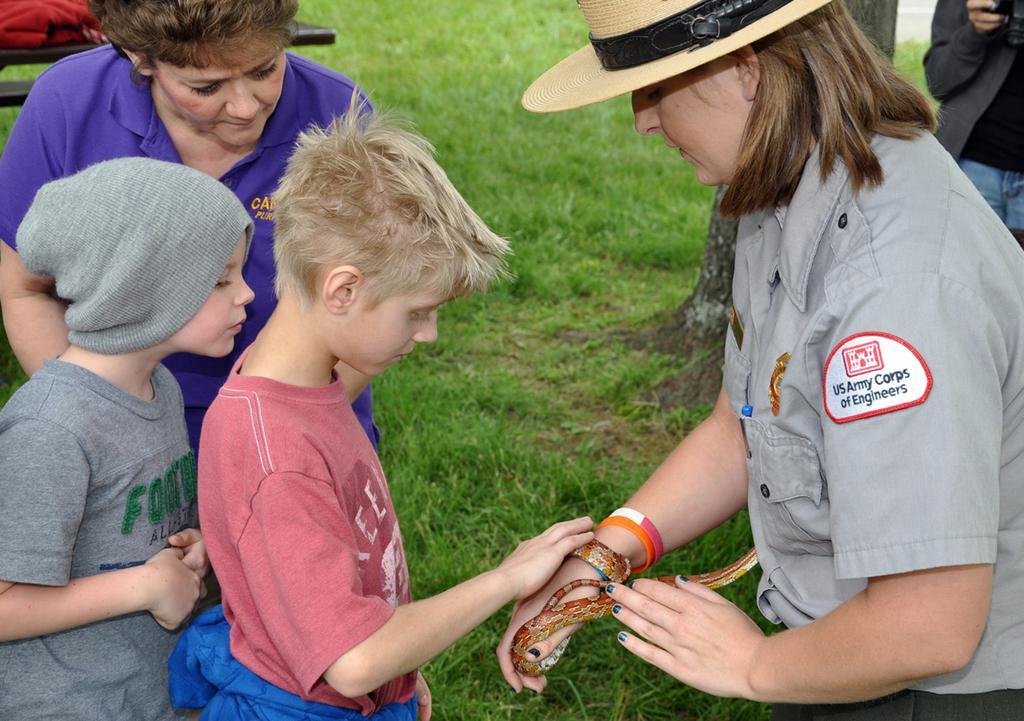Could you give a brief overview of what you see in this image? A picture is taken in a garden. In the image there are group of people, on right side there is a woman holding a snake on her hand, on left side there is a boy who is standing in background we can see a green color grass. 